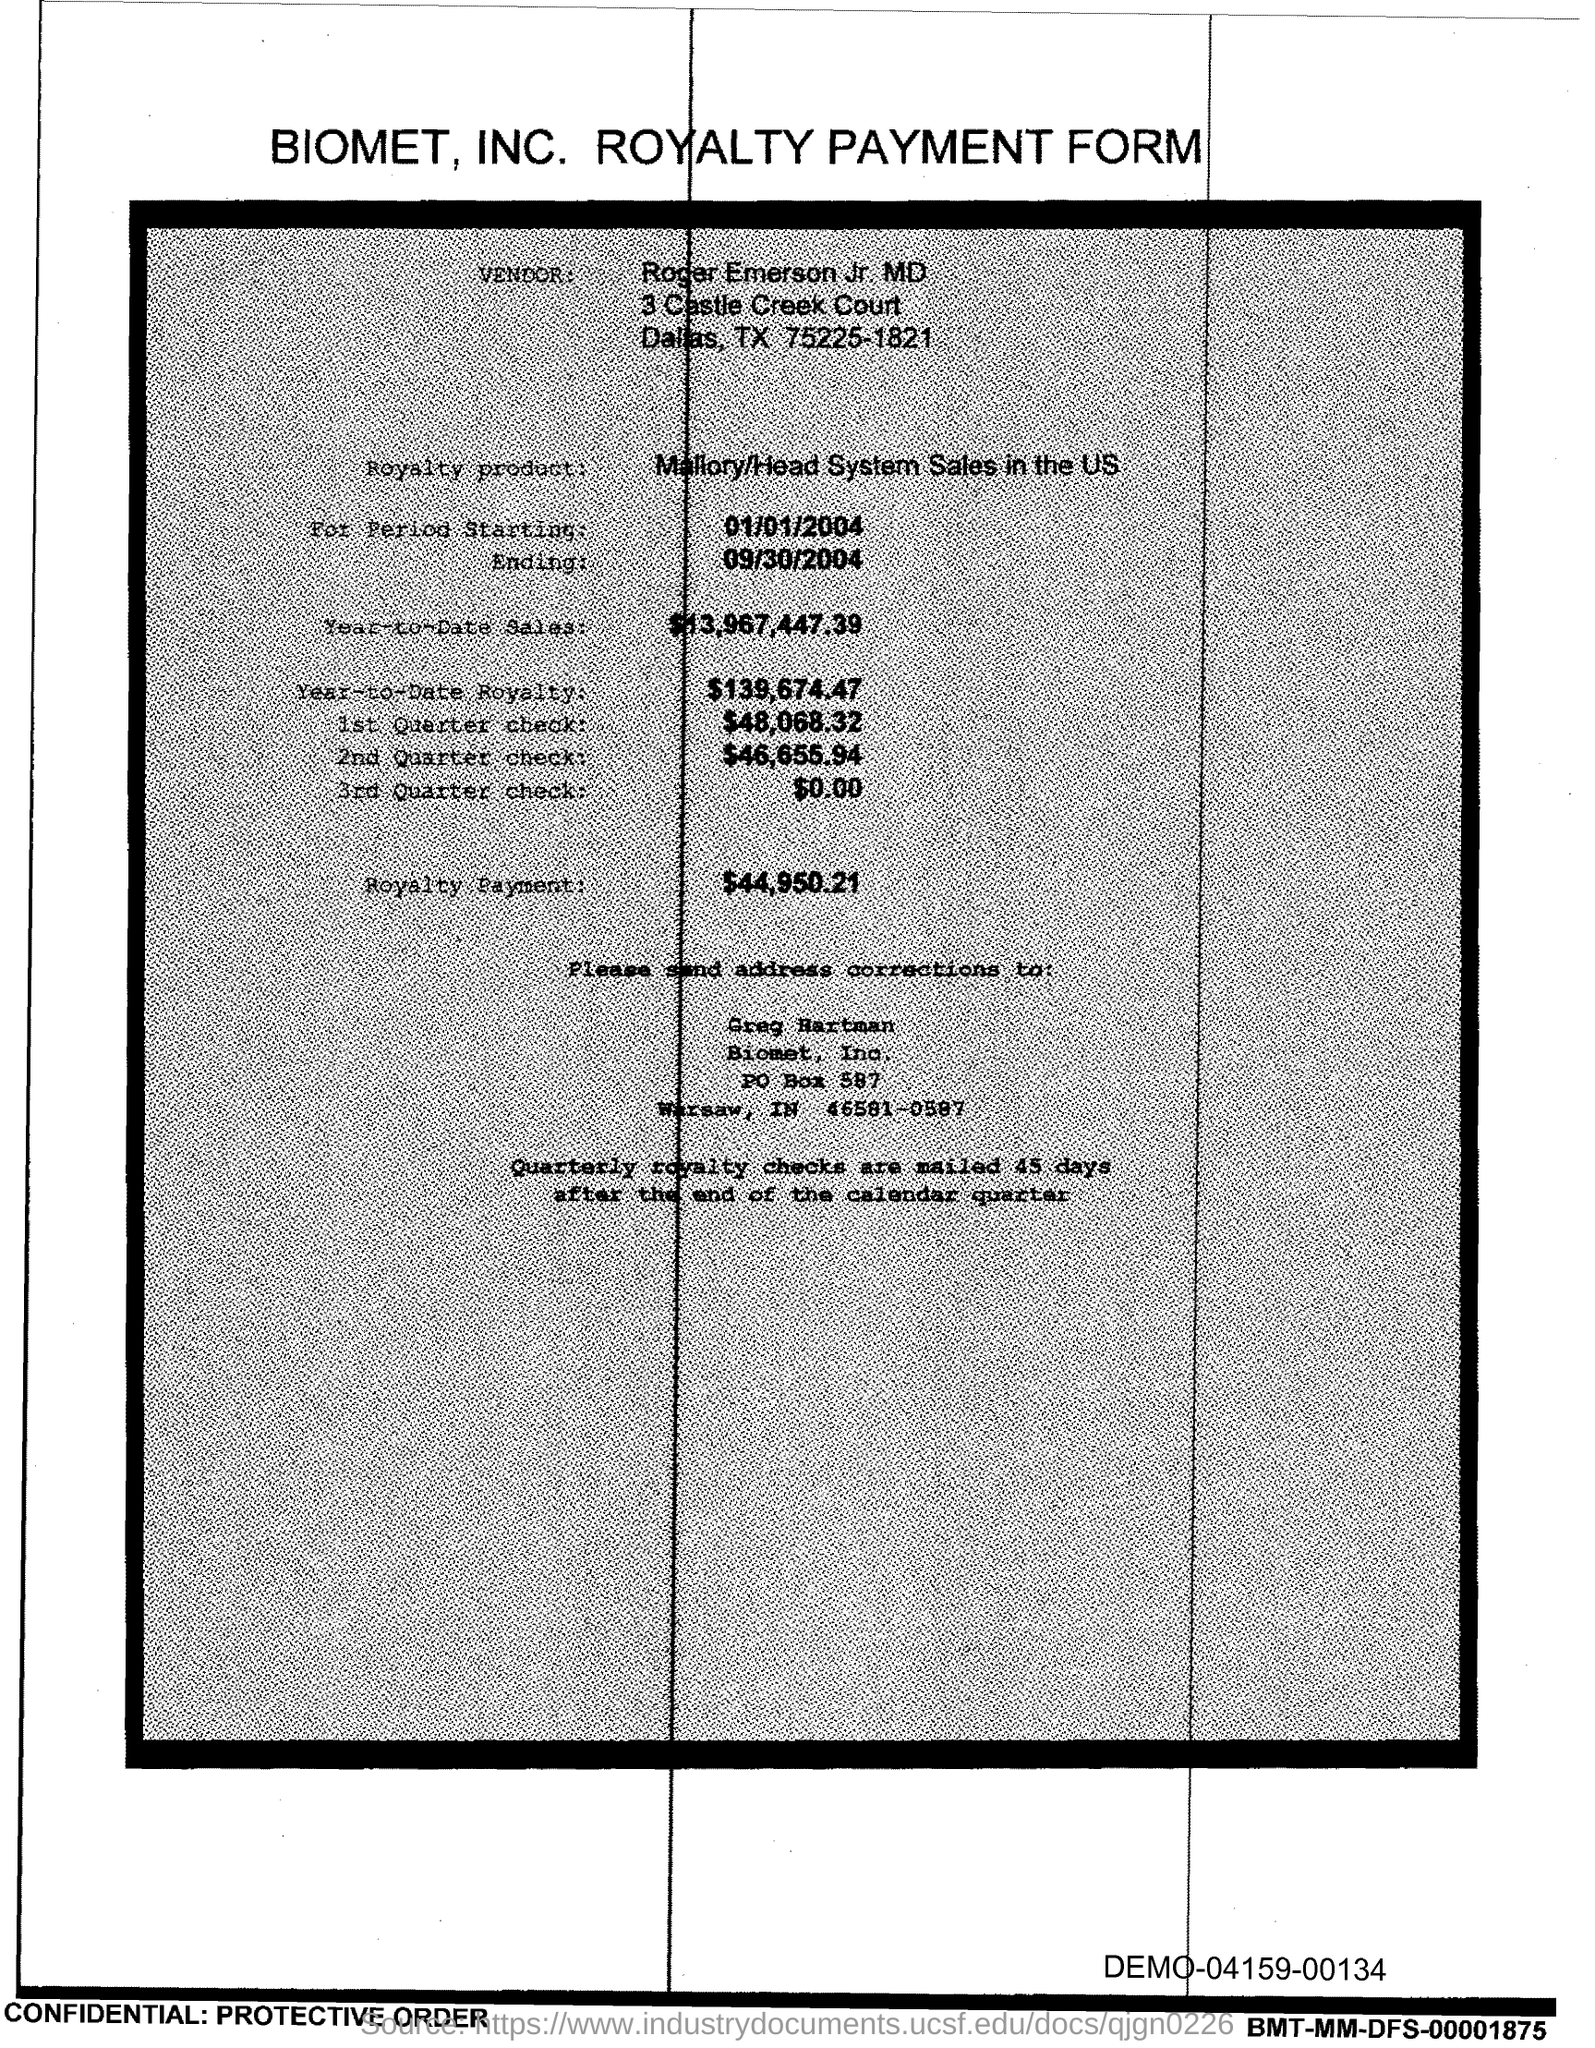What type of form is this?
Provide a succinct answer. Biomet, inc. royalty payment form. What is the company name?
Make the answer very short. Biomet, Inc. What is the vendor name?
Make the answer very short. Roger Emerson. Which city is the vendor from?
Make the answer very short. Dallas. How much is the royalty payment?
Your answer should be compact. $44,950.21. How much is the year to date sales amount?
Give a very brief answer. $13,967,447.39. What is the royalty product?
Provide a succinct answer. Mallory/head system sales in the US. To whom should the address corrections be sent?
Your answer should be compact. Greg Hartman. 